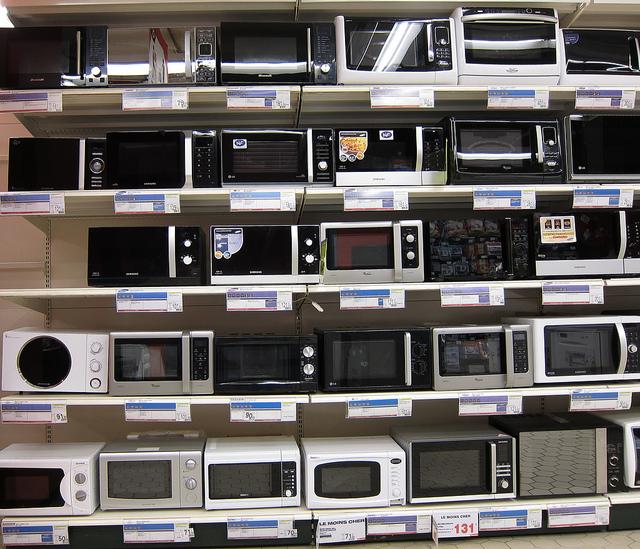How many shelves are there?
Keep it brief. 5. How many microwaves are there?
Answer briefly. 29. Do only single people buy these items?
Concise answer only. No. 